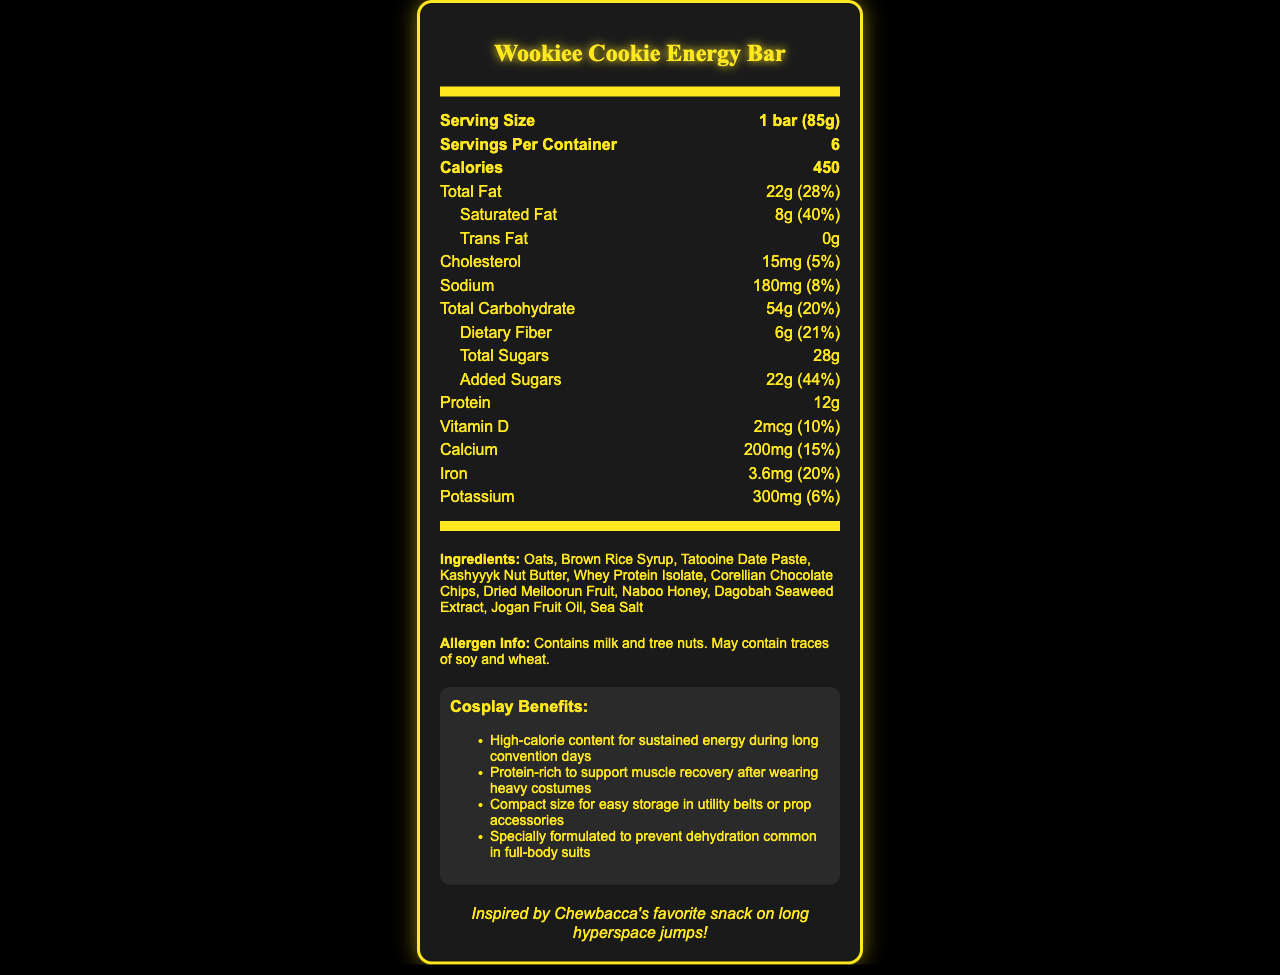What is the serving size of a Wookiee Cookie Energy Bar? The document states that the serving size is 1 bar, equivalent to 85 grams.
Answer: 1 bar (85g) How many servings are in a container of Wookiee Cookie Energy Bars? The document specifies that there are 6 servings per container.
Answer: 6 What is the calorie content of one Wookiee Cookie Energy Bar? The document clearly states that one bar contains 450 calories.
Answer: 450 calories What percentage of the Daily Value is total fat in one Wookiee Cookie Energy Bar? The document shows that the total fat content is 22 grams, which is 28% of the Daily Value.
Answer: 28% What ingredients are included in the Wookiee Cookie Energy Bar? The document lists all the ingredients in the ingredients section.
Answer: Oats, Brown Rice Syrup, Tatooine Date Paste, Kashyyyk Nut Butter, Whey Protein Isolate, Corellian Chocolate Chips, Dried Meiloorun Fruit, Naboo Honey, Dagobah Seaweed Extract, Jogan Fruit Oil, Sea Salt What is the amount of added sugars in one Wookiee Cookie Energy Bar? The document states that there are 22 grams of added sugars, which is 44% of the Daily Value.
Answer: 22g Does the Wookiee Cookie Energy Bar contain any tree nuts? The allergen information indicates that the product contains tree nuts.
Answer: Yes What is the protein content of one Wookiee Cookie Energy Bar? The document mentions that one bar contains 12 grams of protein.
Answer: 12g Which of the following vitamins and minerals are included in the Wookiee Cookie Energy Bar? A. Vitamin C B. Vitamin D C. Iron D. Zinc The document lists Vitamin D and Iron among its nutrients but does not include Vitamin C or Zinc.
Answer: B, C How much sodium is in one Wookiee Cookie Energy Bar? A. 150mg B. 180mg C. 210mg D. 250mg The document states that the sodium content is 180mg.
Answer: B. 180mg Is the Wookiee Cookie Energy Bar free of trans fats? The document confirms that the trans fat content is 0g.
Answer: Yes Summarize the main idea of the document. The document outlines the nutrition facts, health benefits for cosplayers, ingredient details, and a Star Wars-themed trivia related to the Wookiee Cookie Energy Bar.
Answer: The document provides detailed nutritional information on the Wookiee Cookie Energy Bar, including its high-calorie content, fat, carbohydrates, sugars, protein, vitamins, and minerals. It also mentions the specific benefits for cosplayers, ingredient list, and allergen information, along with a fun Star Wars trivia fact. What is the carbohydrate content in one serving of Wookiee Cookie Energy Bar? The document states the total carbohydrate content in grams (54g), but it doesn't split this into simple and complex carbohydrates.
Answer: Cannot be determined When was the Wookiee Cookie Energy Bar first manufactured? The document does not provide any information about the manufacture date of the Wookiee Cookie Energy Bar.
Answer: Not enough information 